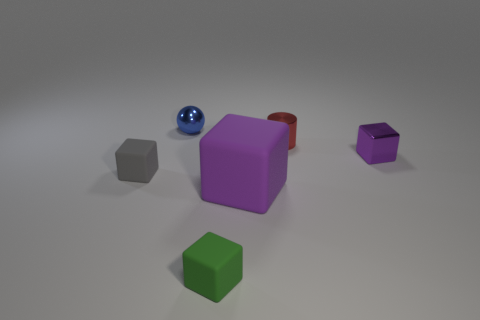What material is the gray object that is the same shape as the large purple thing?
Your answer should be compact. Rubber. Are there any gray matte blocks that are behind the small thing that is left of the blue object?
Ensure brevity in your answer.  No. There is a tiny green rubber thing; are there any purple things in front of it?
Your answer should be very brief. No. There is a small thing that is in front of the tiny gray block; is its shape the same as the small red object?
Ensure brevity in your answer.  No. What number of large green objects have the same shape as the large purple thing?
Make the answer very short. 0. Is there a small purple cube made of the same material as the blue ball?
Offer a terse response. Yes. There is a small thing in front of the small rubber thing that is on the left side of the tiny green rubber cube; what is it made of?
Offer a very short reply. Rubber. How big is the block that is behind the small gray object?
Your answer should be very brief. Small. Do the metallic sphere and the block to the left of the small ball have the same color?
Your response must be concise. No. Is there another matte block that has the same color as the large rubber cube?
Your answer should be very brief. No. 